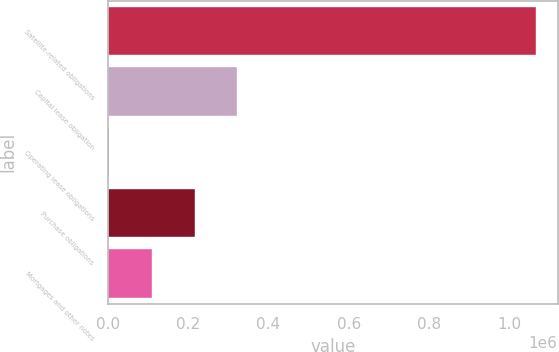<chart> <loc_0><loc_0><loc_500><loc_500><bar_chart><fcel>Satellite-related obligations<fcel>Capital lease obligation<fcel>Operating lease obligations<fcel>Purchase obligations<fcel>Mortgages and other notes<nl><fcel>1.06746e+06<fcel>322028<fcel>2559<fcel>215538<fcel>109049<nl></chart> 